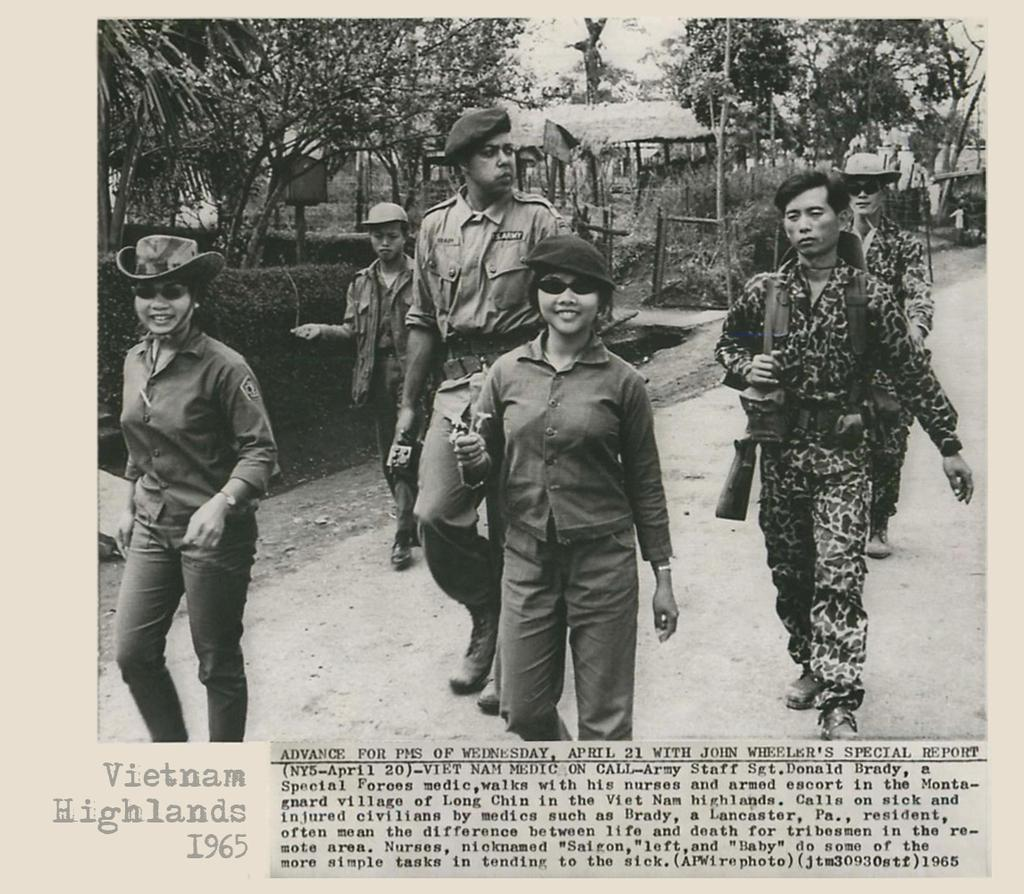What are the people in the image doing? The people in the image are walking. What type of accessory can be seen in the image? There is a hat in the image. What object is present in the image that could be used as a weapon? There is a gun in the image. What type of natural environment is visible in the image? There are trees in the image. What type of fiction is being read by the people walking in the image? There is no indication in the image that the people are reading any fiction, as they are walking and no books or reading materials are visible. 